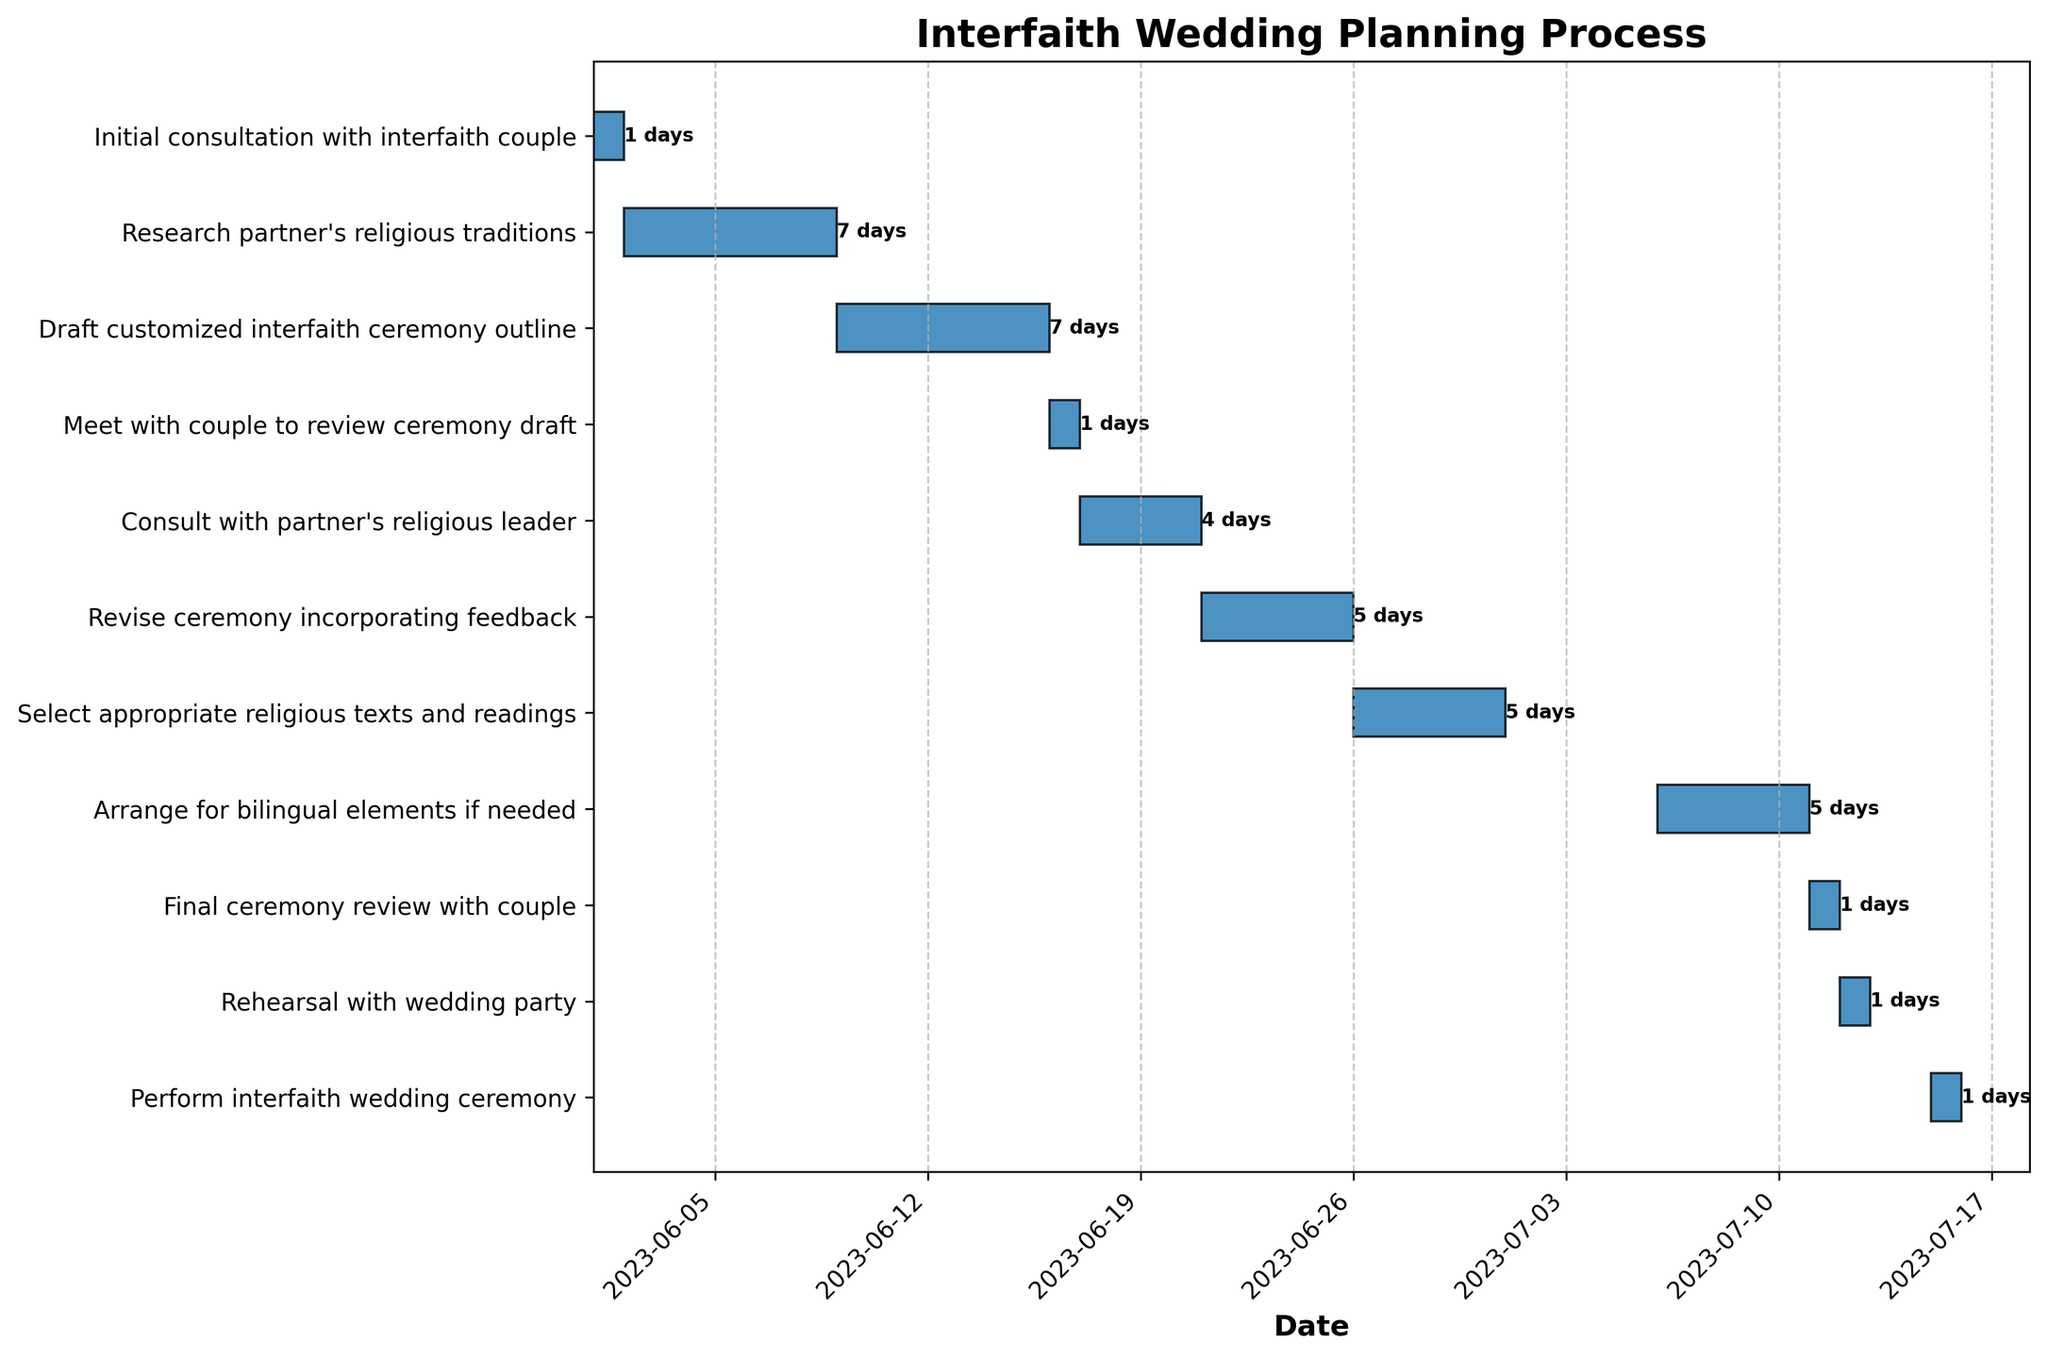What's the title of the Gantt Chart? The title of a chart is usually prominently displayed at the top. In this figure, it is labeled as "Interfaith Wedding Planning Process".
Answer: Interfaith Wedding Planning Process How long does the "Research partner's religious traditions" task take? To find the duration of the task, locate it on the y-axis and observe the text given next to the bar for this task. It is labeled as lasting "7 days".
Answer: 7 days Which task has the shortest duration? To identify the shortest task, we look for the task with the smallest horizontal bar length. According to the figure, "Initial consultation with interfaith couple", "Meet with couple to review ceremony draft", "Final ceremony review with couple", "Rehearsal with wedding party", and "Perform interfaith wedding ceremony" all last for just "1 day".
Answer: Initial consultation with interfaith couple (or any other 1-day tasks) When does the "Consult with partner's religious leader" task start and end? Locate the task on the y-axis, and then look at the top of its horizontal bar to note the start and end dates. "Consult with partner's religious leader" starts on "2023-06-17" and ends on "2023-06-20".
Answer: 2023-06-17 to 2023-06-20 Which task runs from June 26 to June 30? Look for the task bar that spans from June 26 to June 30 on the time axis. The corresponding task on the y-axis is "Select appropriate religious texts and readings".
Answer: Select appropriate religious texts and readings Are there any tasks that overlap with the "Revise ceremony incorporating feedback" task? To identify overlapping tasks, compare the dates of "Revise ceremony incorporating feedback" (June 21 to June 25) with other tasks. No other tasks run exactly during these dates, so there is no visible overlap.
Answer: No How many days in total is the "Draft customized interfaith ceremony outline" scheduled for? The duration of each task is given next to each bar. The "Draft customized interfaith ceremony outline" lasts for "7 days".
Answer: 7 days Which task directly follows the "Final ceremony review with couple"? To find the subsequent task, follow the timeline to the next task after "Final ceremony review with couple", which is "Rehearsal with wedding party" on July 12.
Answer: Rehearsal with wedding party What is the duration between the "Final ceremony review with couple" and the "Perform interfaith wedding ceremony"? The "Final ceremony review with couple" is on July 11 and the "Perform interfaith wedding ceremony" is on July 15, so the duration between them is July 15 - July 11 = 4 days.
Answer: 4 days 